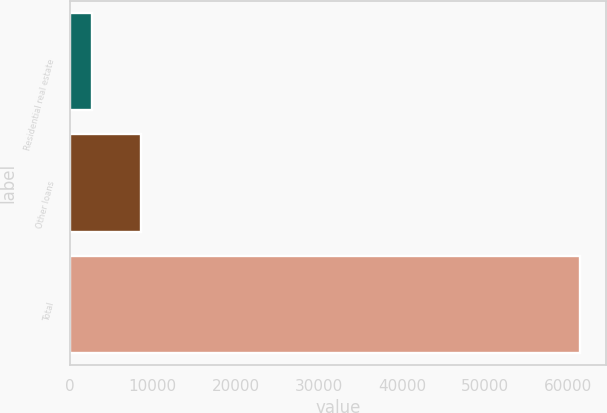Convert chart. <chart><loc_0><loc_0><loc_500><loc_500><bar_chart><fcel>Residential real estate<fcel>Other loans<fcel>Total<nl><fcel>2676<fcel>8552.2<fcel>61438<nl></chart> 